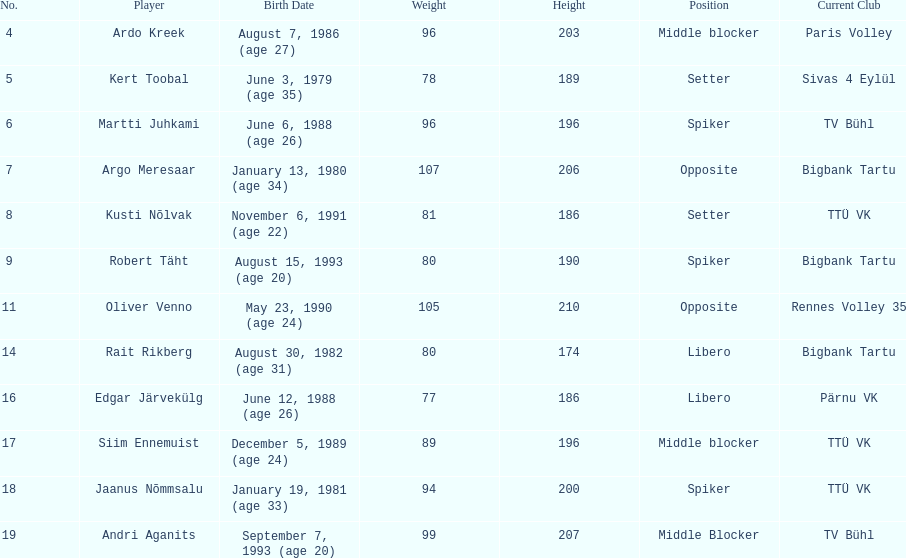Which participants performed the same spot as ardo kreek? Siim Ennemuist, Andri Aganits. 